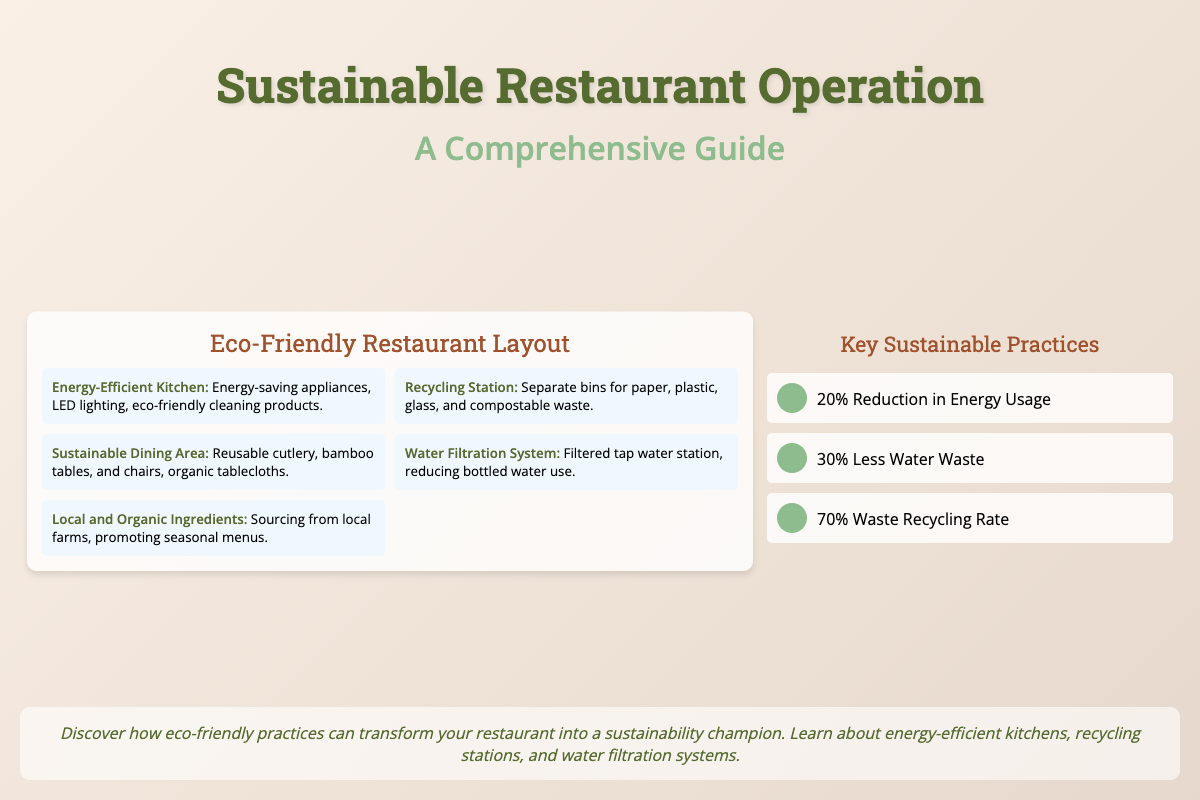What is the title of the book? The title is presented prominently at the top of the cover.
Answer: Sustainable Restaurant Operation What is the subtitle of the book? The subtitle is shown beneath the title and highlights the comprehensive nature of the content.
Answer: A Comprehensive Guide What are the three areas emphasized in the eco-friendly restaurant layout? Areas depicted in the layout are explained in the schematic section.
Answer: Energy-Efficient Kitchen, Recycling Station, Sustainable Dining Area What percentage reduction in energy usage is mentioned? This information is presented in the infographic section of the cover.
Answer: 20% How much less water waste is highlighted in the document? The infographic lists this specific reduction clearly.
Answer: 30% What type of water system is included in the sustainable practices? The document specifically describes this category under eco-friendly features.
Answer: Water Filtration System What is emphasized regarding the use of ingredients? This information is discussed as a key practice for sustainable operations.
Answer: Local and Organic Ingredients What color theme is used for the book cover? The background and design elements reflect a natural and earthy palette.
Answer: Earthy tones What is the waste recycling rate mentioned? This figure is stated in the infographic to highlight sustainability efforts.
Answer: 70% Waste Recycling Rate 